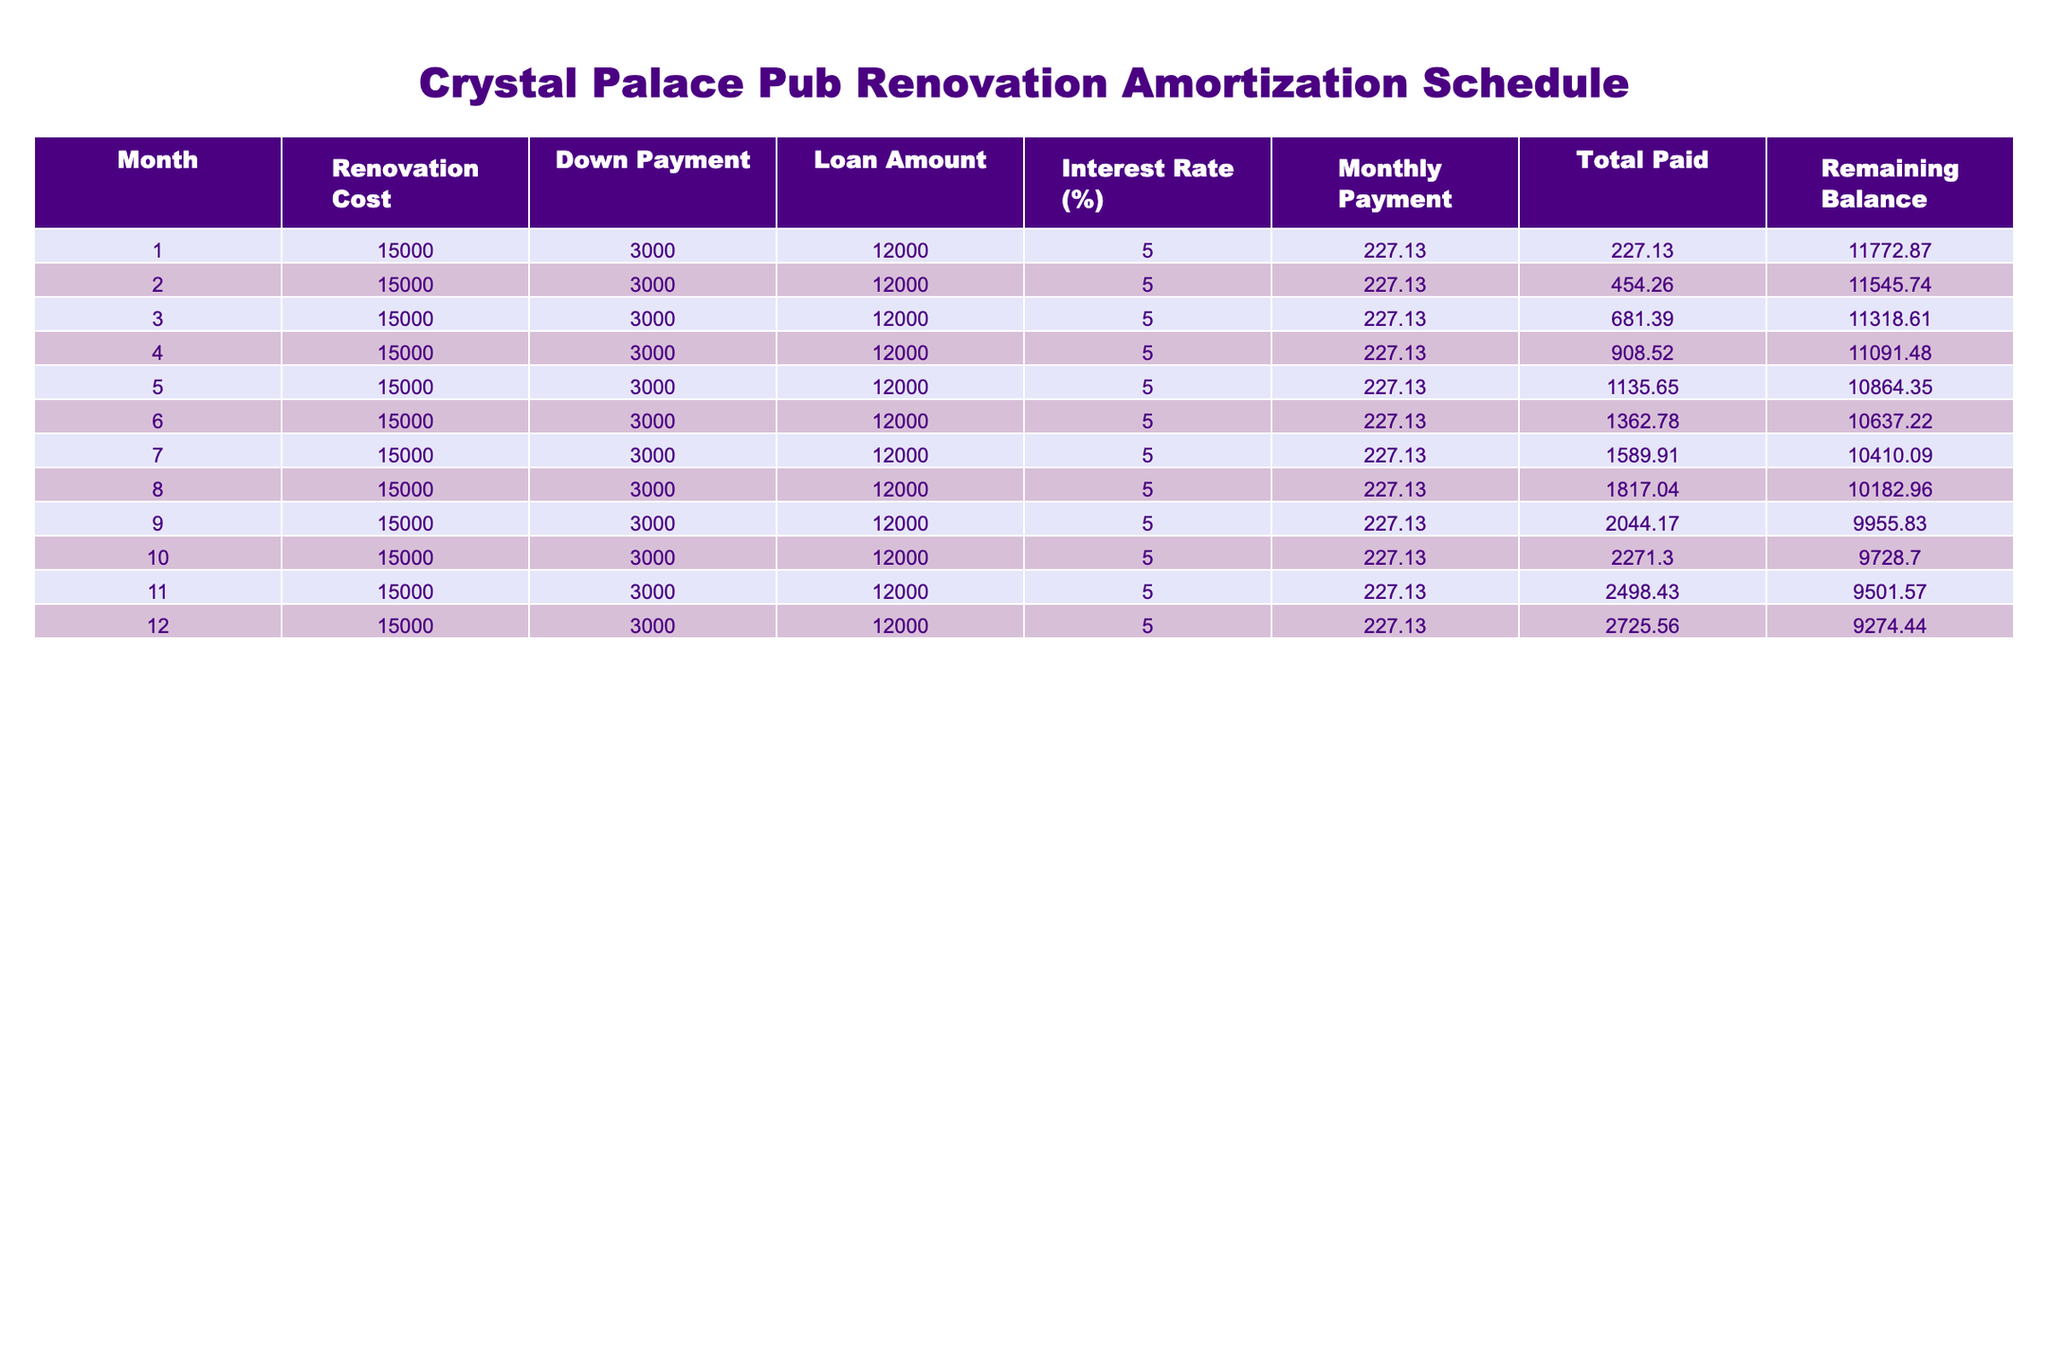What is the monthly payment amount? The monthly payment amount is listed directly in the table under the "Monthly Payment" column for each month. For all the months, it consistently shows £227.13.
Answer: £227.13 What is the total amount paid after the 6th month? To find the total paid after the 6th month, we look at the "Total Paid" column for the 6th month, which shows £1,362.78.
Answer: £1,362.78 Is the remaining balance after 12 months less than £9,000? By checking the "Remaining Balance" for the 12th month in the table, we see that it is £9,274.44. Since £9,274.44 is greater than £9,000, the answer is no.
Answer: No What is the reduction in the remaining balance from the end of the first month to the end of the second month? From the "Remaining Balance" column, at the end of the first month it's £11,772.87, and at the end of the second month it's £11,545.74. The reduction can be calculated as £11,772.87 - £11,545.74 = £227.13.
Answer: £227.13 What is the total renovation cost over the entire period? The renovation cost is consistently £15,000 for each month, and since the table covers 12 months, the total renovation cost is simply 12 multiplied by £15,000, which equals £180,000. However, since only £15,000 is noted, this value doesn't seem to represent multiple months’ renovation but just a singular figure.
Answer: £15,000 What was the interest rate for the loan? The interest rate is given under the "Interest Rate (%)" column, and it is constant for each month at 5%.
Answer: 5% 